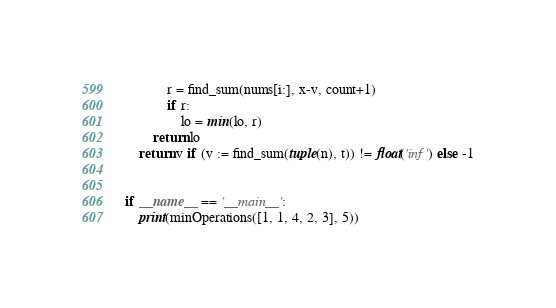<code> <loc_0><loc_0><loc_500><loc_500><_Python_>            r = find_sum(nums[i:], x-v, count+1)
            if r:
                lo = min(lo, r)
        return lo
    return v if (v := find_sum(tuple(n), t)) != float('inf') else -1


if __name__ == '__main__':
    print(minOperations([1, 1, 4, 2, 3], 5))
</code> 